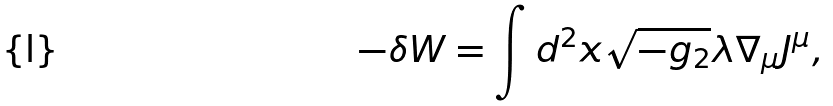Convert formula to latex. <formula><loc_0><loc_0><loc_500><loc_500>- \delta W = \int d ^ { 2 } x \sqrt { - g _ { 2 } } \lambda \nabla _ { \mu } J ^ { \mu } ,</formula> 